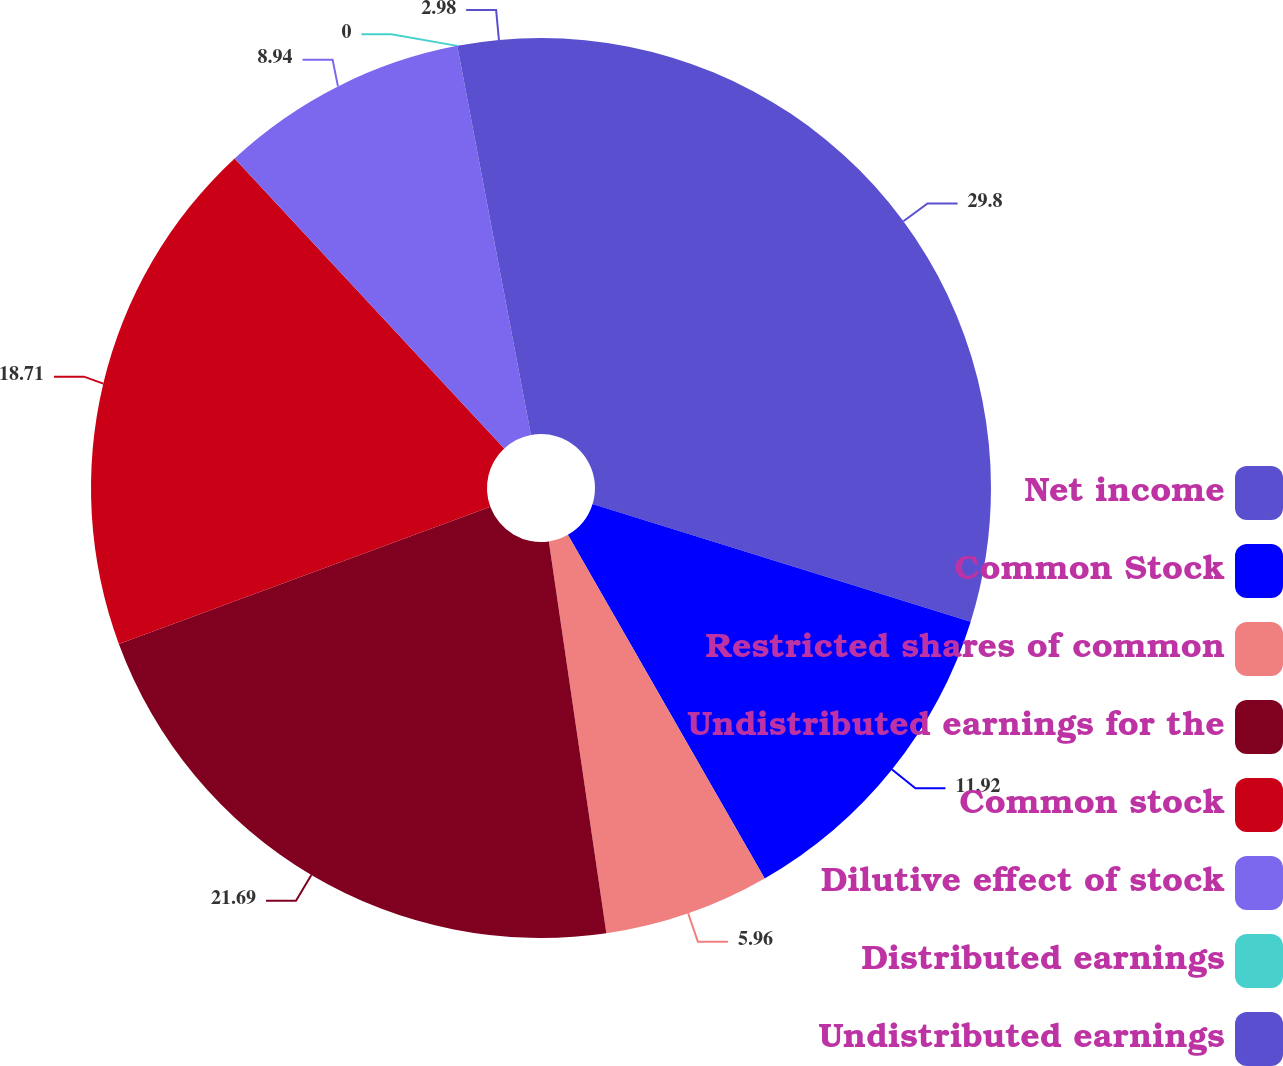Convert chart to OTSL. <chart><loc_0><loc_0><loc_500><loc_500><pie_chart><fcel>Net income<fcel>Common Stock<fcel>Restricted shares of common<fcel>Undistributed earnings for the<fcel>Common stock<fcel>Dilutive effect of stock<fcel>Distributed earnings<fcel>Undistributed earnings<nl><fcel>29.8%<fcel>11.92%<fcel>5.96%<fcel>21.69%<fcel>18.71%<fcel>8.94%<fcel>0.0%<fcel>2.98%<nl></chart> 